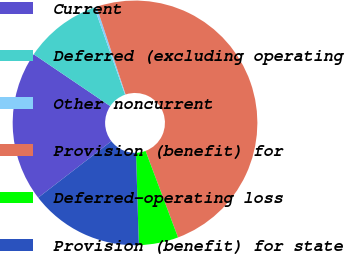Convert chart to OTSL. <chart><loc_0><loc_0><loc_500><loc_500><pie_chart><fcel>Current<fcel>Deferred (excluding operating<fcel>Other noncurrent<fcel>Provision (benefit) for<fcel>Deferred-operating loss<fcel>Provision (benefit) for state<nl><fcel>19.94%<fcel>10.13%<fcel>0.31%<fcel>49.37%<fcel>5.22%<fcel>15.03%<nl></chart> 